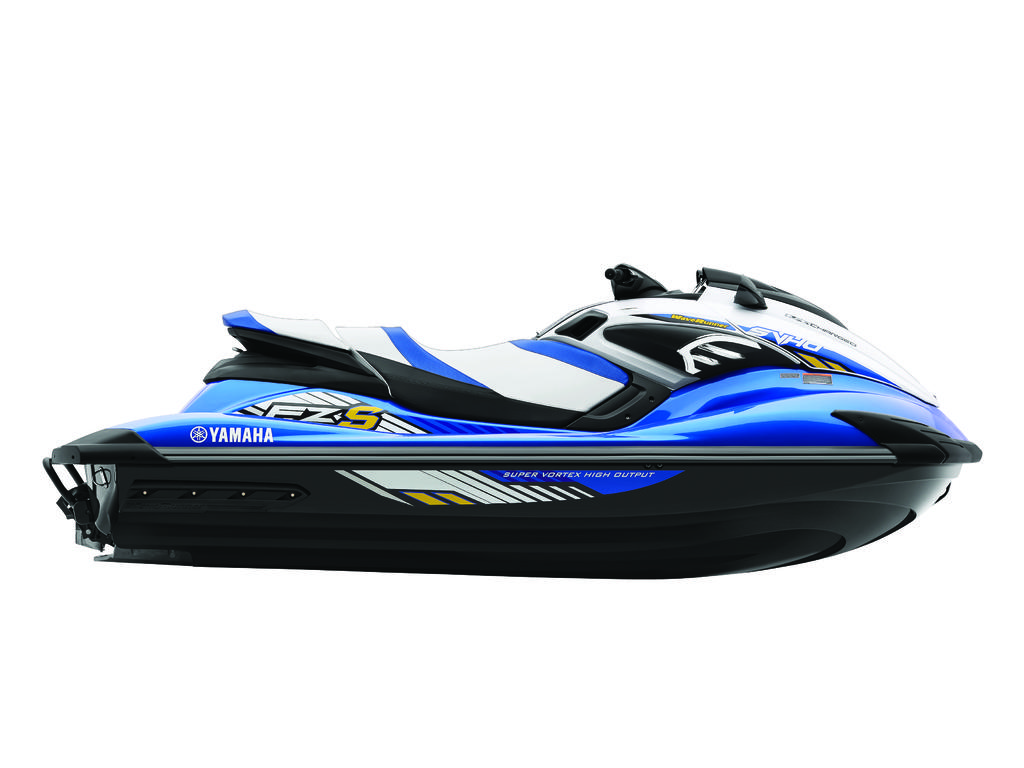What type of vehicle is in the image? There is a water boat in the image. What can be seen in the background of the image? The background of the image is white. Can you hear the friend crying in the image? There is no friend or any indication of crying in the image; it only features a water boat against a white background. 